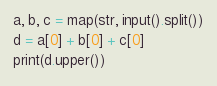Convert code to text. <code><loc_0><loc_0><loc_500><loc_500><_Python_>a, b, c = map(str, input().split())
d = a[0] + b[0] + c[0]
print(d.upper())</code> 